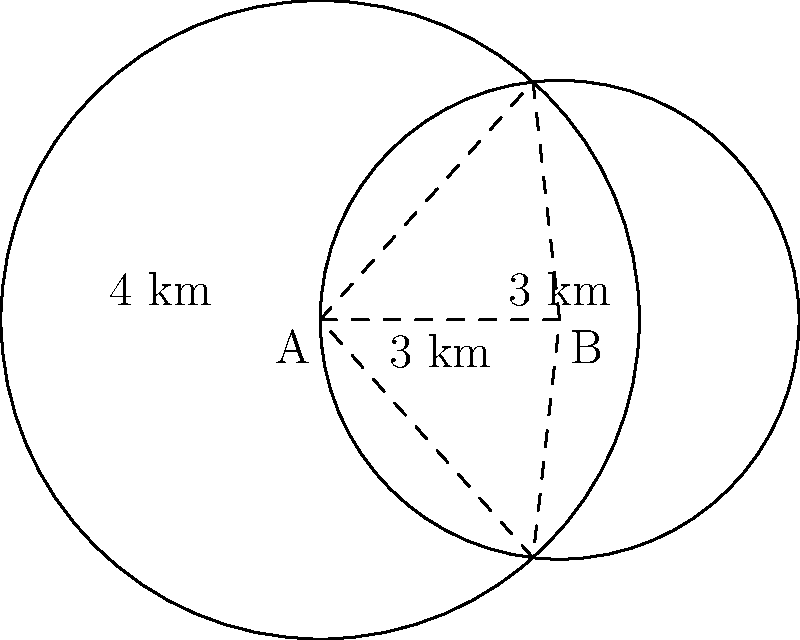Two circular patrol zones for monitoring motorcycle gang activity overlap as shown. Zone A has a radius of 4 km, and Zone B has a radius of 3 km. The centers of the zones are 3 km apart. Calculate the area of the overlapping region where both patrols cover simultaneously. To find the area of intersection between two circles, we can use the following steps:

1) First, we need to calculate the distance from the center of each circle to the line joining the points of intersection. Let's call this distance $h$ for both circles.

2) We can use the Pythagorean theorem to set up an equation:

   $h^2 + (\frac{3}{2})^2 = 4^2$ for circle A
   $h^2 + (\frac{3}{2})^2 = 3^2$ for circle B

3) Solving for $h$:
   
   For circle A: $h = \sqrt{4^2 - (\frac{3}{2})^2} = \sqrt{16 - 2.25} = \sqrt{13.75} \approx 3.708$ km
   
   For circle B: $h = \sqrt{3^2 - (\frac{3}{2})^2} = \sqrt{9 - 2.25} = \sqrt{6.75} \approx 2.598$ km

4) Now we can calculate the area of the circular sector in each circle:

   Circle A: $\theta_A = 2 \arccos(\frac{3}{8}) \approx 2.0944$ radians
   Area of sector A = $\frac{1}{2} \cdot 4^2 \cdot 2.0944 \approx 16.755$ sq km

   Circle B: $\theta_B = 2 \arccos(\frac{3}{6}) \approx 2.0944$ radians
   Area of sector B = $\frac{1}{2} \cdot 3^2 \cdot 2.0944 \approx 9.425$ sq km

5) The area of the triangle in each sector:

   Area of triangle = $\frac{3}{2} \cdot h$
   
   For A: $\frac{3}{2} \cdot 3.708 \approx 5.562$ sq km
   For B: $\frac{3}{2} \cdot 2.598 \approx 3.897$ sq km

6) The area of intersection is the sum of the circular segments:

   (Area of sector A - Area of triangle A) + (Area of sector B - Area of triangle B)
   = $(16.755 - 5.562) + (9.425 - 3.897)$
   $\approx 11.193 + 5.528$
   $\approx 16.721$ sq km

Therefore, the area of the overlapping region is approximately 16.721 sq km.
Answer: 16.721 sq km 